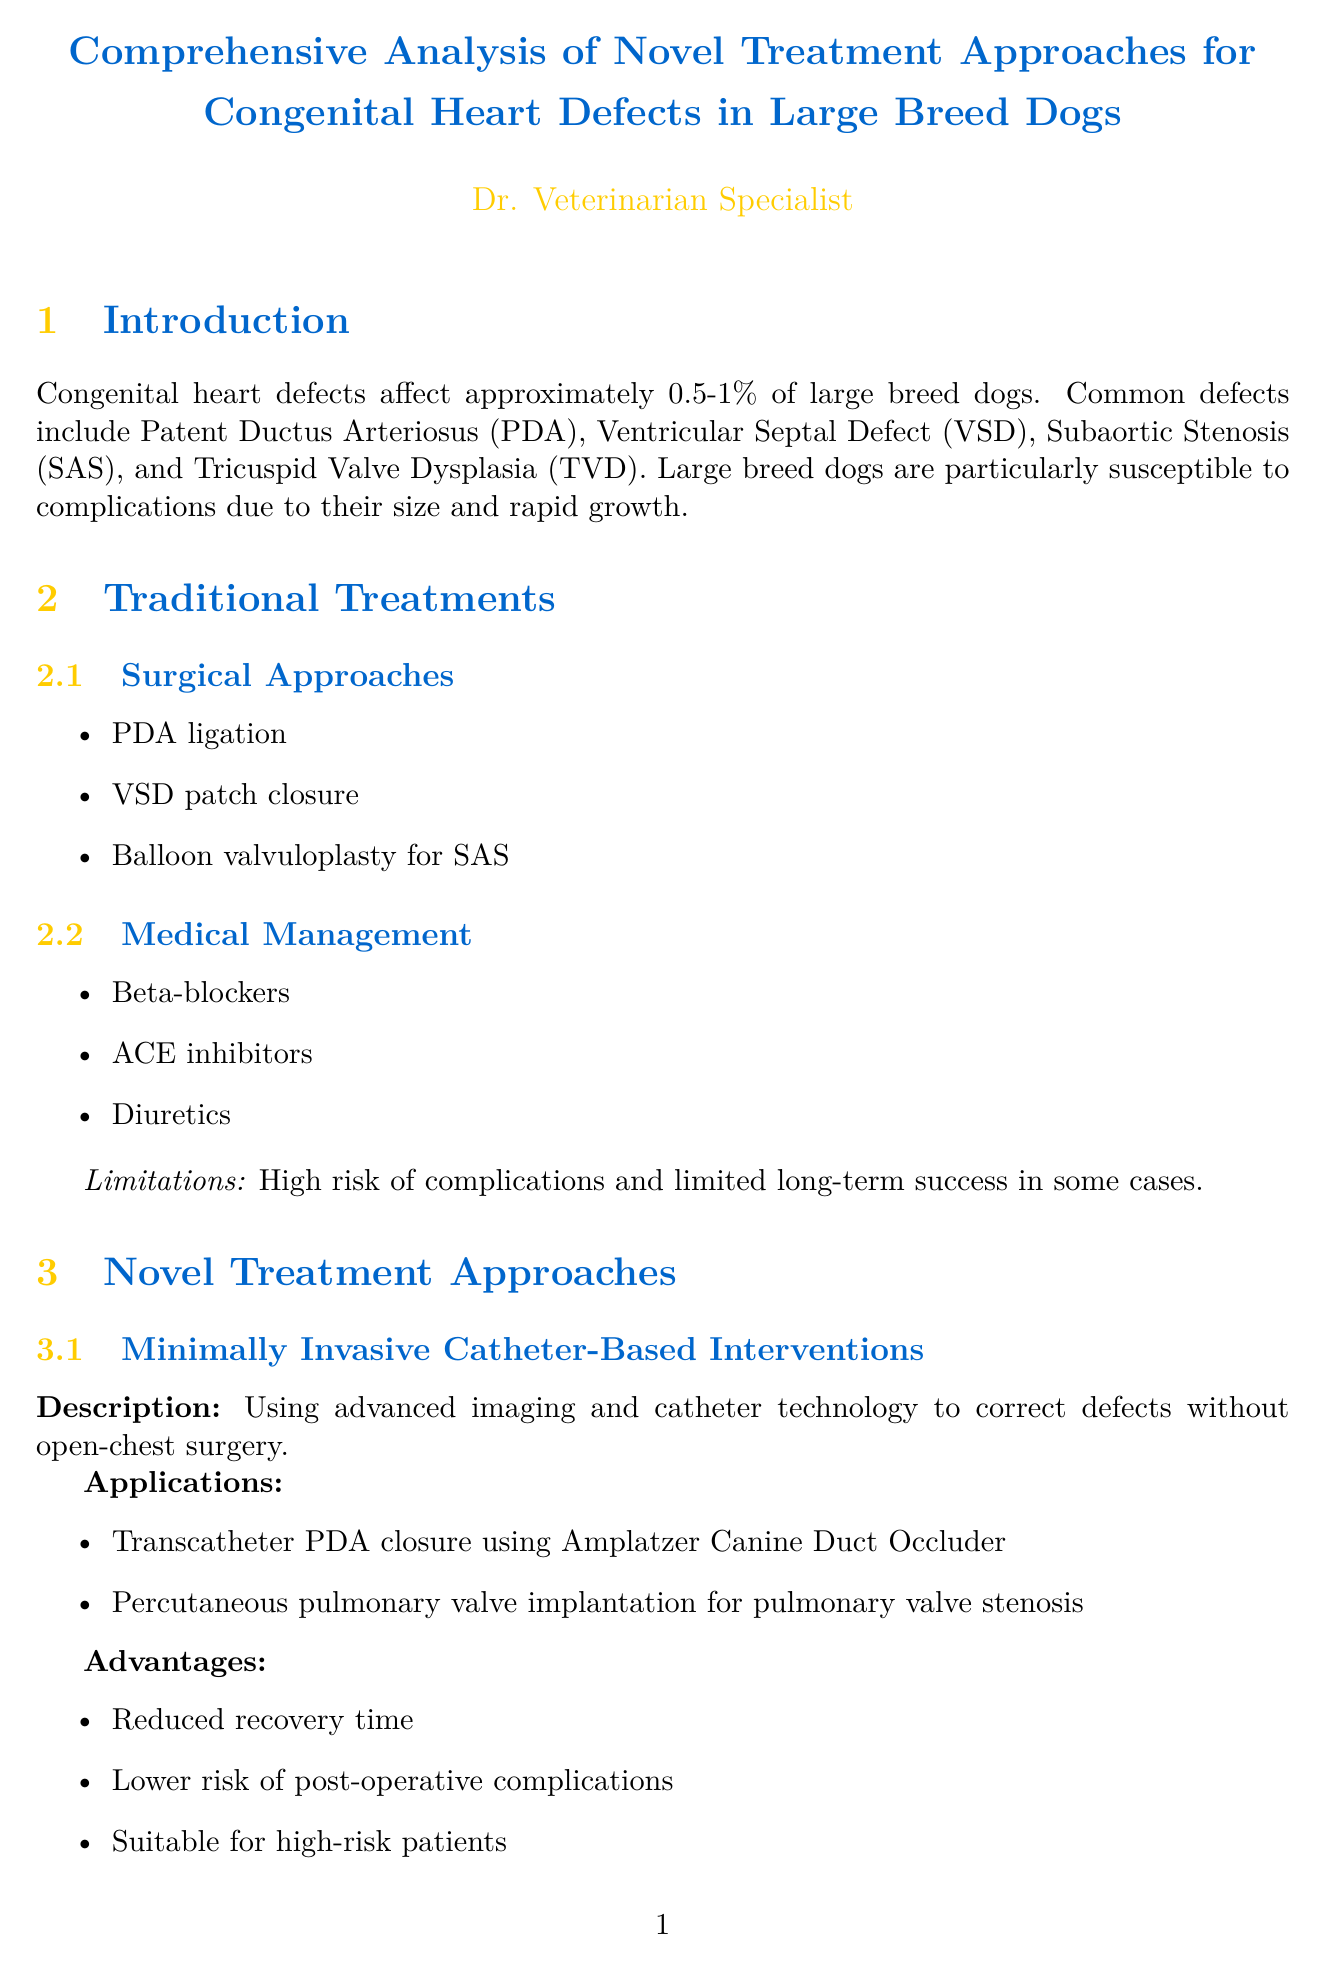what is the prevalence of congenital heart defects in large breed dogs? The document states that congenital heart defects affect approximately 0.5-1% of large breed dogs.
Answer: 0.5-1% name one common congenital heart defect in large breed dogs. The document lists common defects, including Patent Ductus Arteriosus (PDA).
Answer: Patent Ductus Arteriosus what treatment was used for Max's condition? Max had severe Subaortic Stenosis and was treated with a 3D-printed custom subvalvular ring implant.
Answer: 3D-printed custom subvalvular ring implant which novel treatment approach utilizes advanced imaging and catheter technology? The document describes Minimally Invasive Catheter-Based Interventions as utilizing advanced imaging and catheter technology.
Answer: Minimally Invasive Catheter-Based Interventions what was the success rate for Luna's treatment? The success rate for Luna, who underwent minimally invasive catheter-based VSD closure, is given as 92%.
Answer: 92% how do novel treatments compare to traditional treatments in terms of invasiveness? The document states that novel approaches are generally less invasive, while traditional methods often require open-chest surgery.
Answer: Less invasive what is one of the future directions mentioned in the document? The document lists the development of bioengineered cardiac tissues for transplantation as a future direction.
Answer: Development of bioengineered cardiac tissues what recommendation is made for complex cases or high-risk patients? The document recommends considering novel approaches for complex cases or high-risk patients.
Answer: Consider novel approaches 